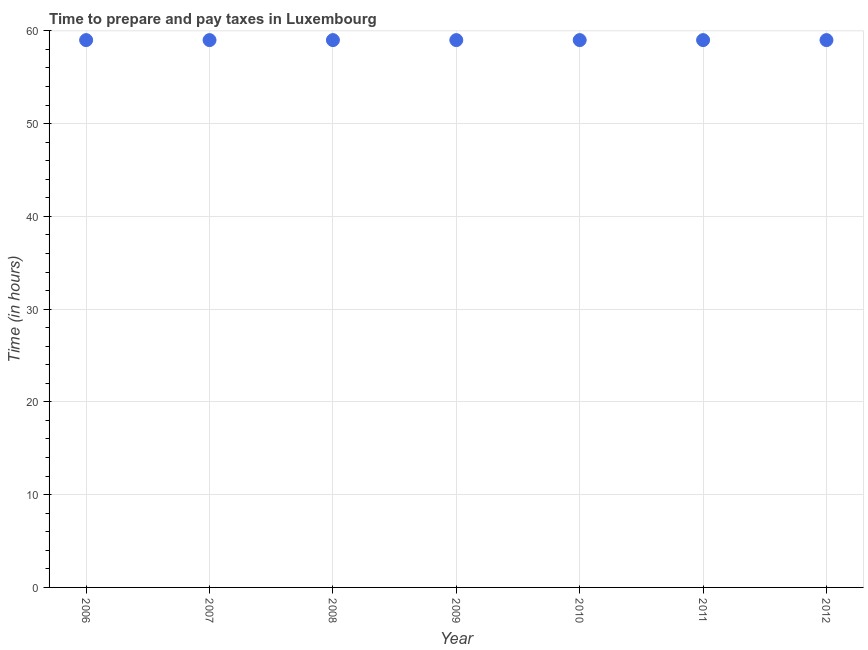What is the time to prepare and pay taxes in 2006?
Offer a terse response. 59. Across all years, what is the maximum time to prepare and pay taxes?
Your response must be concise. 59. Across all years, what is the minimum time to prepare and pay taxes?
Keep it short and to the point. 59. In which year was the time to prepare and pay taxes maximum?
Provide a succinct answer. 2006. In which year was the time to prepare and pay taxes minimum?
Make the answer very short. 2006. What is the sum of the time to prepare and pay taxes?
Keep it short and to the point. 413. What is the difference between the time to prepare and pay taxes in 2010 and 2012?
Make the answer very short. 0. What is the average time to prepare and pay taxes per year?
Make the answer very short. 59. What is the median time to prepare and pay taxes?
Make the answer very short. 59. In how many years, is the time to prepare and pay taxes greater than 12 hours?
Provide a short and direct response. 7. What is the ratio of the time to prepare and pay taxes in 2007 to that in 2011?
Provide a short and direct response. 1. Is the time to prepare and pay taxes in 2007 less than that in 2011?
Give a very brief answer. No. Is the difference between the time to prepare and pay taxes in 2010 and 2012 greater than the difference between any two years?
Provide a short and direct response. Yes. What is the difference between the highest and the second highest time to prepare and pay taxes?
Keep it short and to the point. 0. What is the difference between the highest and the lowest time to prepare and pay taxes?
Make the answer very short. 0. In how many years, is the time to prepare and pay taxes greater than the average time to prepare and pay taxes taken over all years?
Offer a very short reply. 0. How many dotlines are there?
Provide a short and direct response. 1. How many years are there in the graph?
Make the answer very short. 7. Are the values on the major ticks of Y-axis written in scientific E-notation?
Keep it short and to the point. No. Does the graph contain grids?
Your response must be concise. Yes. What is the title of the graph?
Keep it short and to the point. Time to prepare and pay taxes in Luxembourg. What is the label or title of the Y-axis?
Offer a very short reply. Time (in hours). What is the Time (in hours) in 2007?
Your answer should be very brief. 59. What is the Time (in hours) in 2010?
Offer a very short reply. 59. What is the difference between the Time (in hours) in 2006 and 2008?
Provide a succinct answer. 0. What is the difference between the Time (in hours) in 2006 and 2011?
Your response must be concise. 0. What is the difference between the Time (in hours) in 2007 and 2008?
Make the answer very short. 0. What is the difference between the Time (in hours) in 2007 and 2010?
Ensure brevity in your answer.  0. What is the difference between the Time (in hours) in 2007 and 2011?
Offer a terse response. 0. What is the difference between the Time (in hours) in 2008 and 2010?
Your response must be concise. 0. What is the difference between the Time (in hours) in 2008 and 2011?
Offer a terse response. 0. What is the difference between the Time (in hours) in 2011 and 2012?
Your answer should be compact. 0. What is the ratio of the Time (in hours) in 2006 to that in 2007?
Your response must be concise. 1. What is the ratio of the Time (in hours) in 2006 to that in 2009?
Provide a succinct answer. 1. What is the ratio of the Time (in hours) in 2006 to that in 2010?
Give a very brief answer. 1. What is the ratio of the Time (in hours) in 2006 to that in 2011?
Your answer should be compact. 1. What is the ratio of the Time (in hours) in 2007 to that in 2011?
Offer a very short reply. 1. What is the ratio of the Time (in hours) in 2008 to that in 2009?
Give a very brief answer. 1. What is the ratio of the Time (in hours) in 2008 to that in 2010?
Your answer should be very brief. 1. What is the ratio of the Time (in hours) in 2009 to that in 2011?
Give a very brief answer. 1. What is the ratio of the Time (in hours) in 2009 to that in 2012?
Your answer should be compact. 1. What is the ratio of the Time (in hours) in 2010 to that in 2011?
Offer a very short reply. 1. What is the ratio of the Time (in hours) in 2010 to that in 2012?
Your response must be concise. 1. 